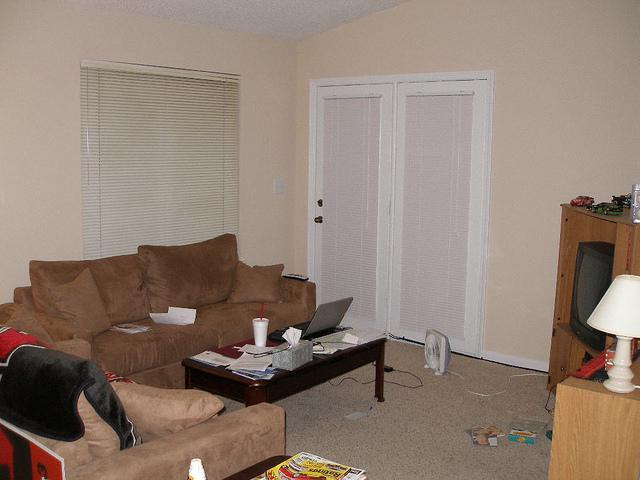What poses the biggest threat for a person to trip on? wires 